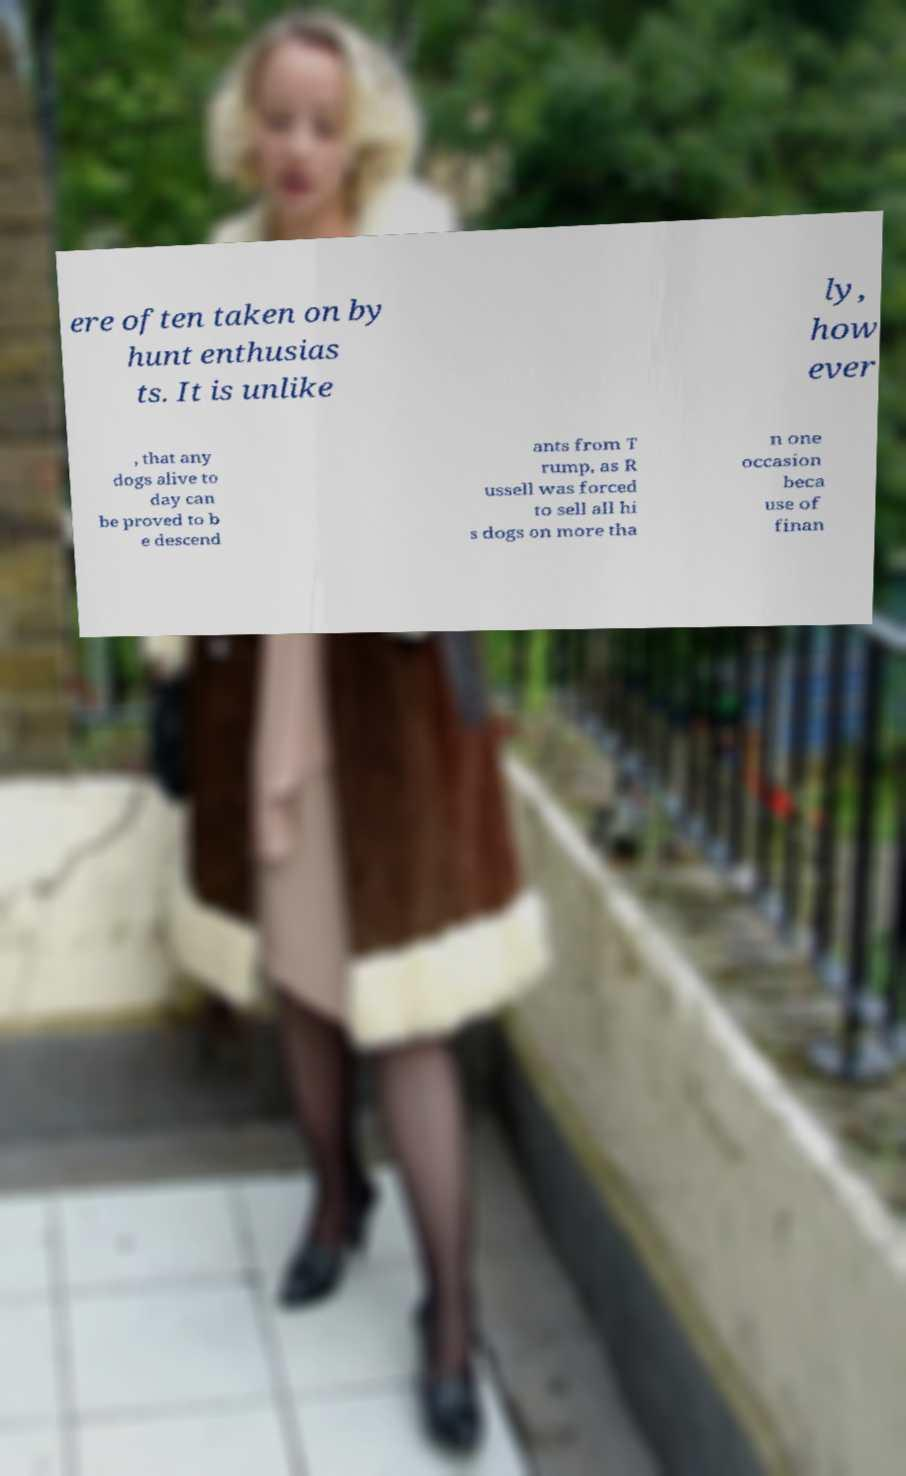Please read and relay the text visible in this image. What does it say? ere often taken on by hunt enthusias ts. It is unlike ly, how ever , that any dogs alive to day can be proved to b e descend ants from T rump, as R ussell was forced to sell all hi s dogs on more tha n one occasion beca use of finan 